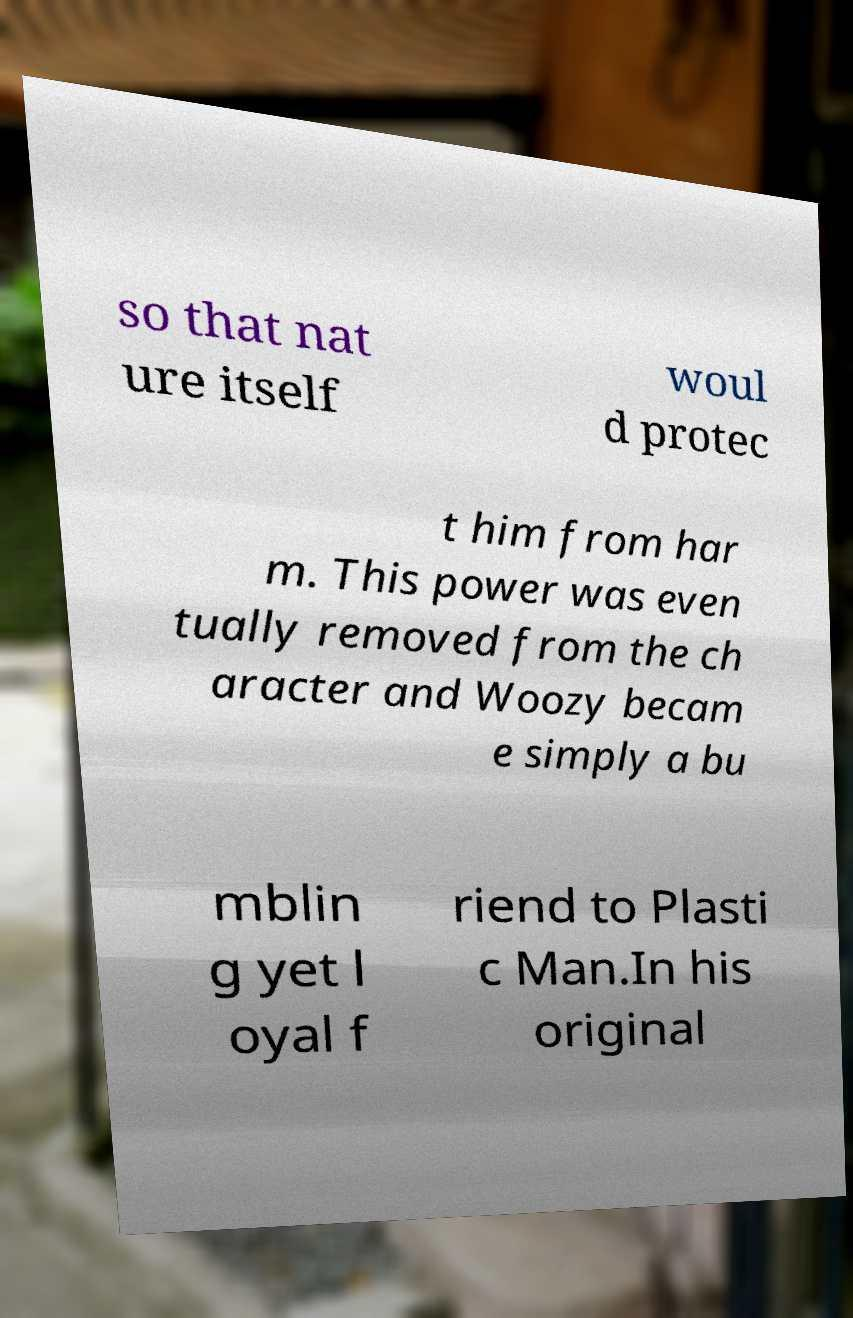Please identify and transcribe the text found in this image. so that nat ure itself woul d protec t him from har m. This power was even tually removed from the ch aracter and Woozy becam e simply a bu mblin g yet l oyal f riend to Plasti c Man.In his original 